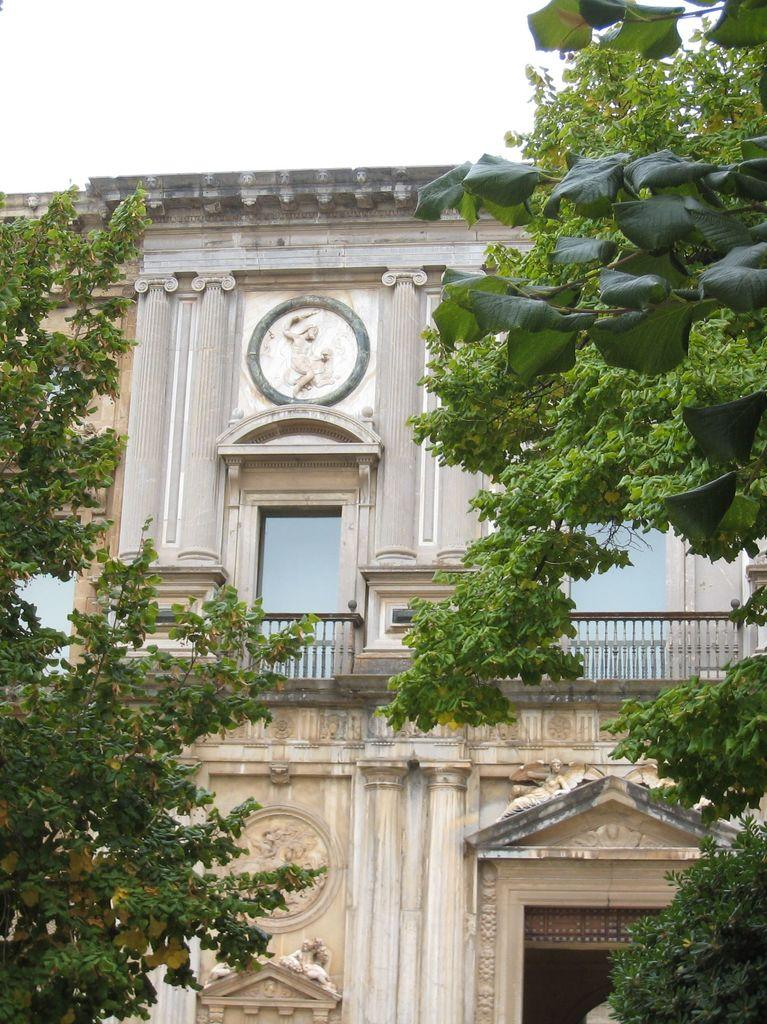What type of building is visible in the image? There is a building with glass windows in the image. What feature can be seen surrounding the building? The building has a fence. What natural elements are present in front of the building? There are trees in front of the building. What type of breakfast is the actor eating in the image? There is no actor or breakfast present in the image; it only features a building with glass windows, a fence, and trees. 